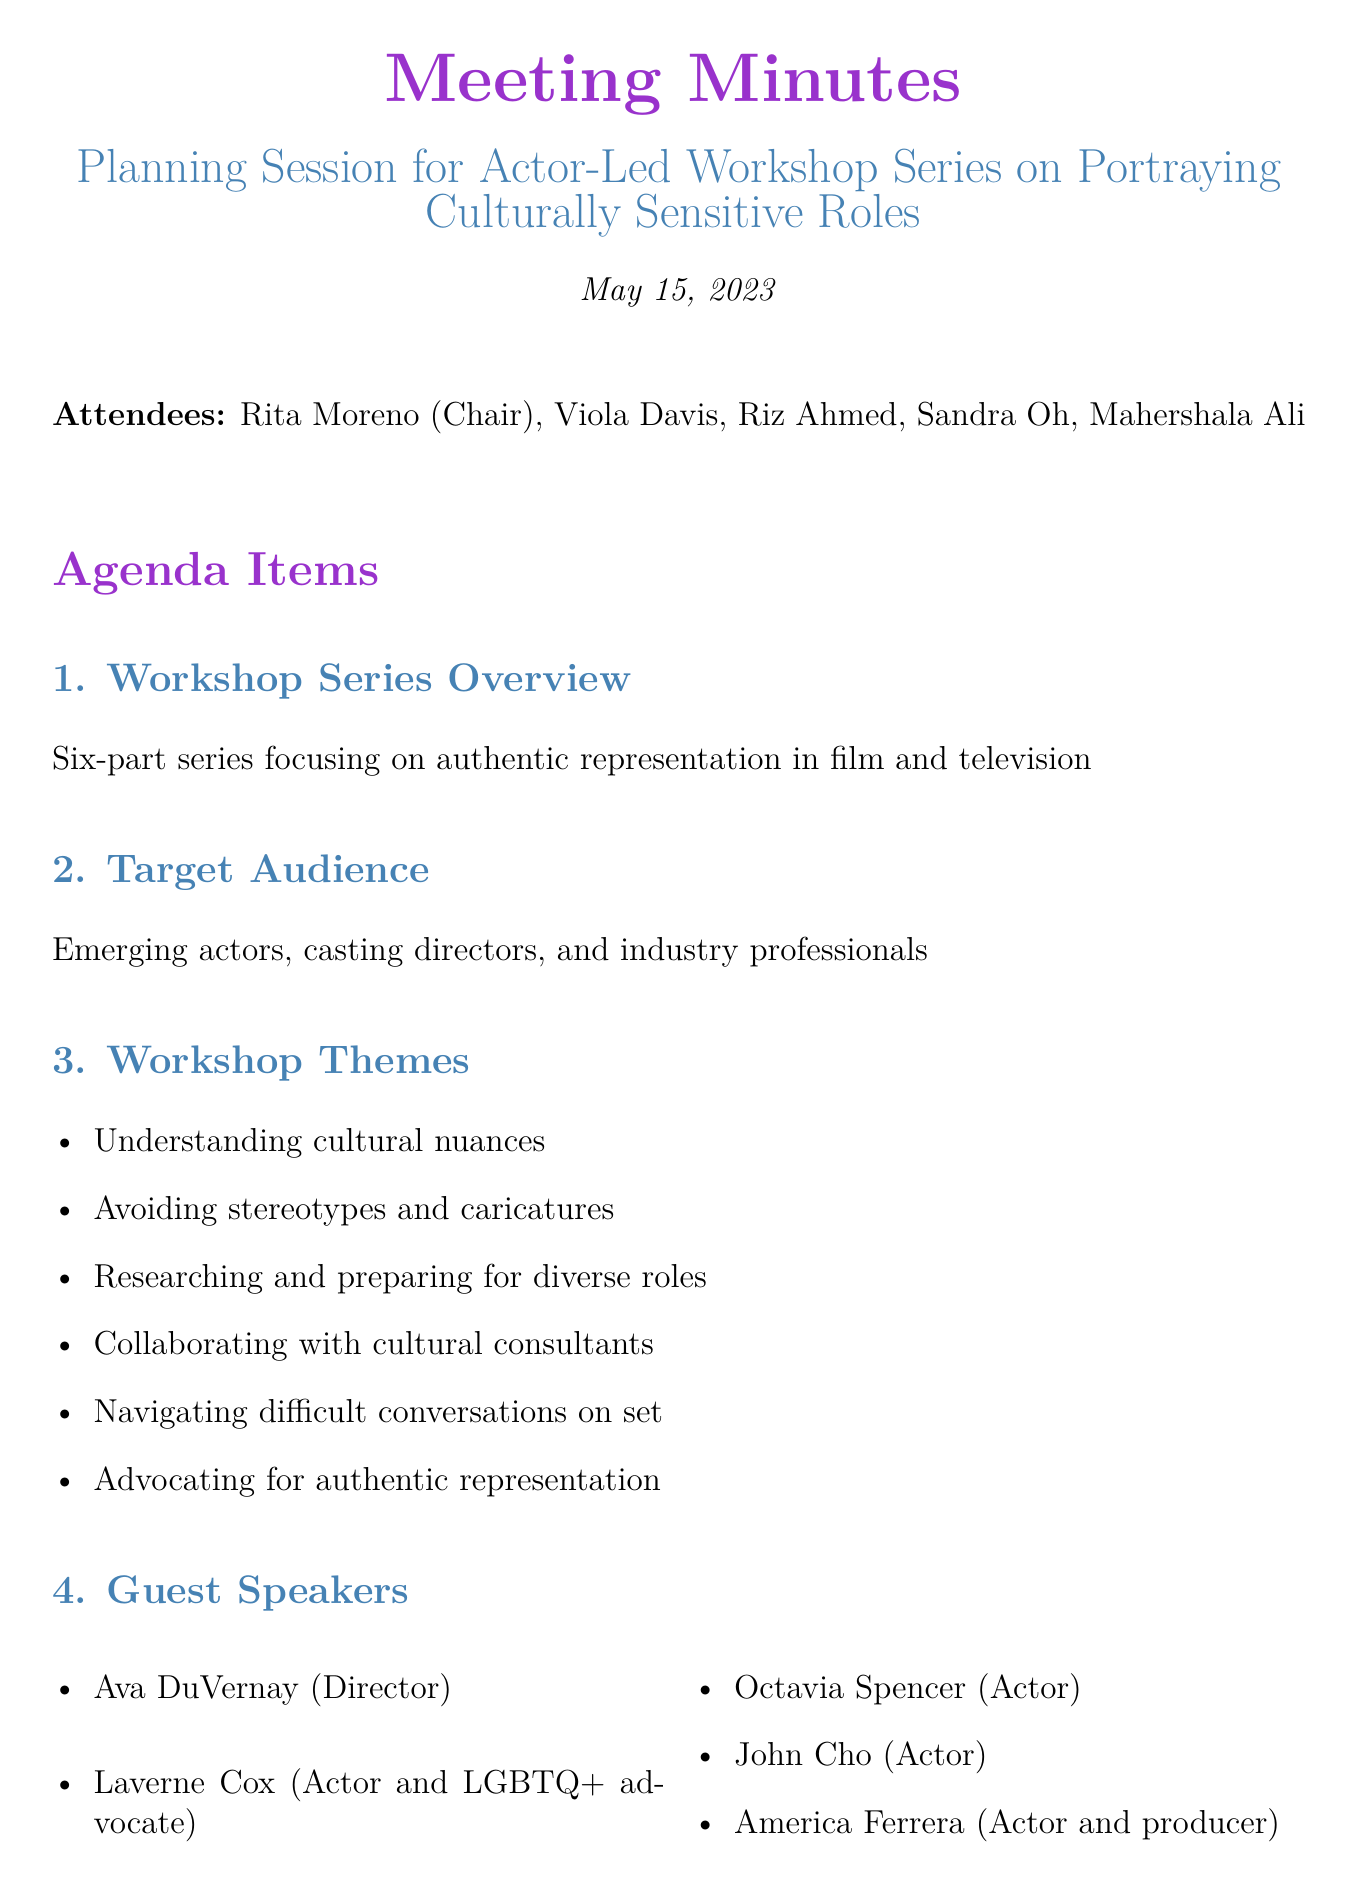what is the date of the meeting? The date listed in the document for the meeting is May 15, 2023.
Answer: May 15, 2023 who is the chair of the meeting? The document specifies that Rita Moreno is the chair of the meeting.
Answer: Rita Moreno how many workshop themes are outlined? The document lists a total of six workshop themes for the series.
Answer: six which organization will host the venue? The document indicates that the SAG-AFTRA Foundation will host the venue.
Answer: SAG-AFTRA Foundation name one guest speaker mentioned in the document. The document includes several guest speakers, such as Ava DuVernay, indicating that she is one of them.
Answer: Ava DuVernay what is the timeline for the workshop series? The workshop series is set to launch in September 2023 and will continue with monthly sessions until February 2024.
Answer: September 2023 to February 2024 who is responsible for researching potential studio sponsors? Mahershala Ali is noted in the document as responsible for researching potential studio sponsors.
Answer: Mahershala Ali what is the primary target audience for the workshops? The document states that the target audience includes emerging actors, casting directors, and industry professionals.
Answer: emerging actors, casting directors, and industry professionals 